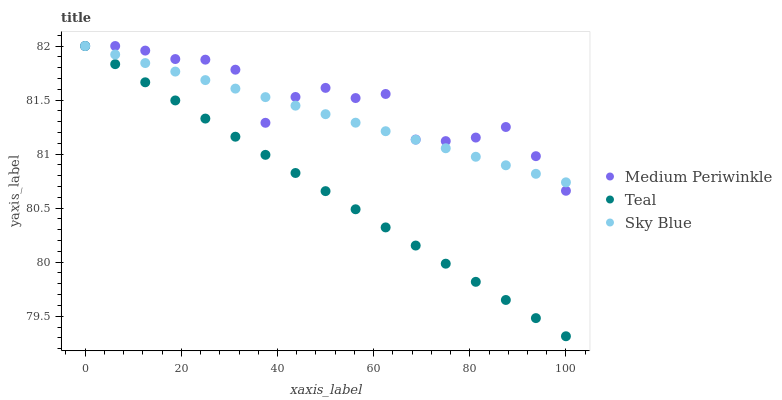Does Teal have the minimum area under the curve?
Answer yes or no. Yes. Does Medium Periwinkle have the maximum area under the curve?
Answer yes or no. Yes. Does Medium Periwinkle have the minimum area under the curve?
Answer yes or no. No. Does Teal have the maximum area under the curve?
Answer yes or no. No. Is Sky Blue the smoothest?
Answer yes or no. Yes. Is Medium Periwinkle the roughest?
Answer yes or no. Yes. Is Teal the smoothest?
Answer yes or no. No. Is Teal the roughest?
Answer yes or no. No. Does Teal have the lowest value?
Answer yes or no. Yes. Does Medium Periwinkle have the lowest value?
Answer yes or no. No. Does Teal have the highest value?
Answer yes or no. Yes. Does Sky Blue intersect Medium Periwinkle?
Answer yes or no. Yes. Is Sky Blue less than Medium Periwinkle?
Answer yes or no. No. Is Sky Blue greater than Medium Periwinkle?
Answer yes or no. No. 